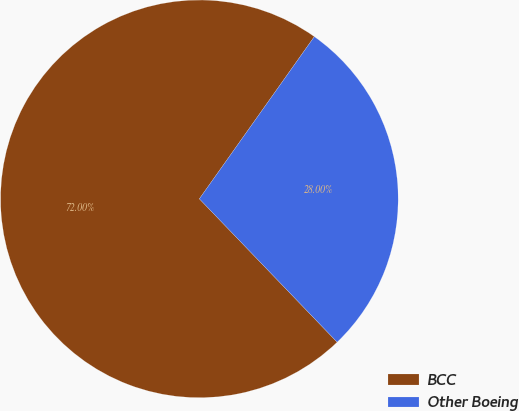Convert chart. <chart><loc_0><loc_0><loc_500><loc_500><pie_chart><fcel>BCC<fcel>Other Boeing<nl><fcel>72.0%<fcel>28.0%<nl></chart> 